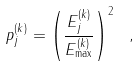<formula> <loc_0><loc_0><loc_500><loc_500>p _ { j } ^ { ( k ) } = \left ( \frac { E _ { j } ^ { ( k ) } } { E _ { \max } ^ { ( k ) } } \right ) ^ { 2 } \ ,</formula> 